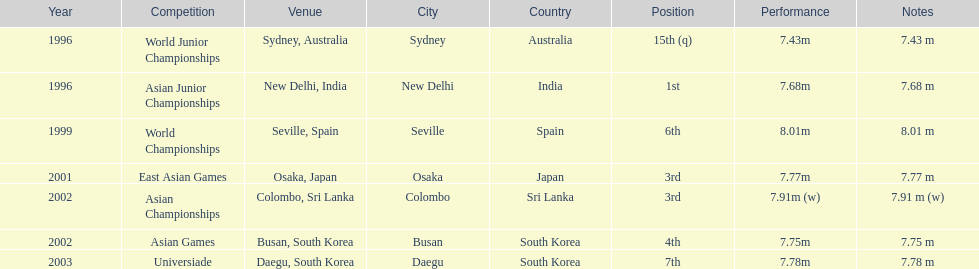How many competitions did he place in the top three? 3. 